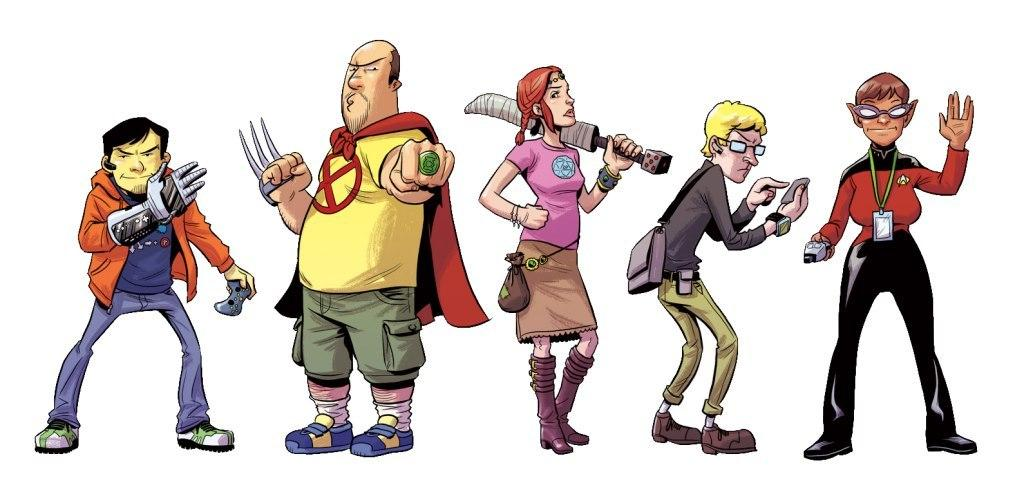How many people are present in the image? There are five people in the image: four men and one woman. What are the people in the image doing? The people are standing and holding objects. What is the topic of the discussion taking place among the people in the image? There is no discussion taking place among the people in the image; they are simply standing and holding objects. How much profit can be seen in the image? There is no mention of profit or any financial aspect in the image. 